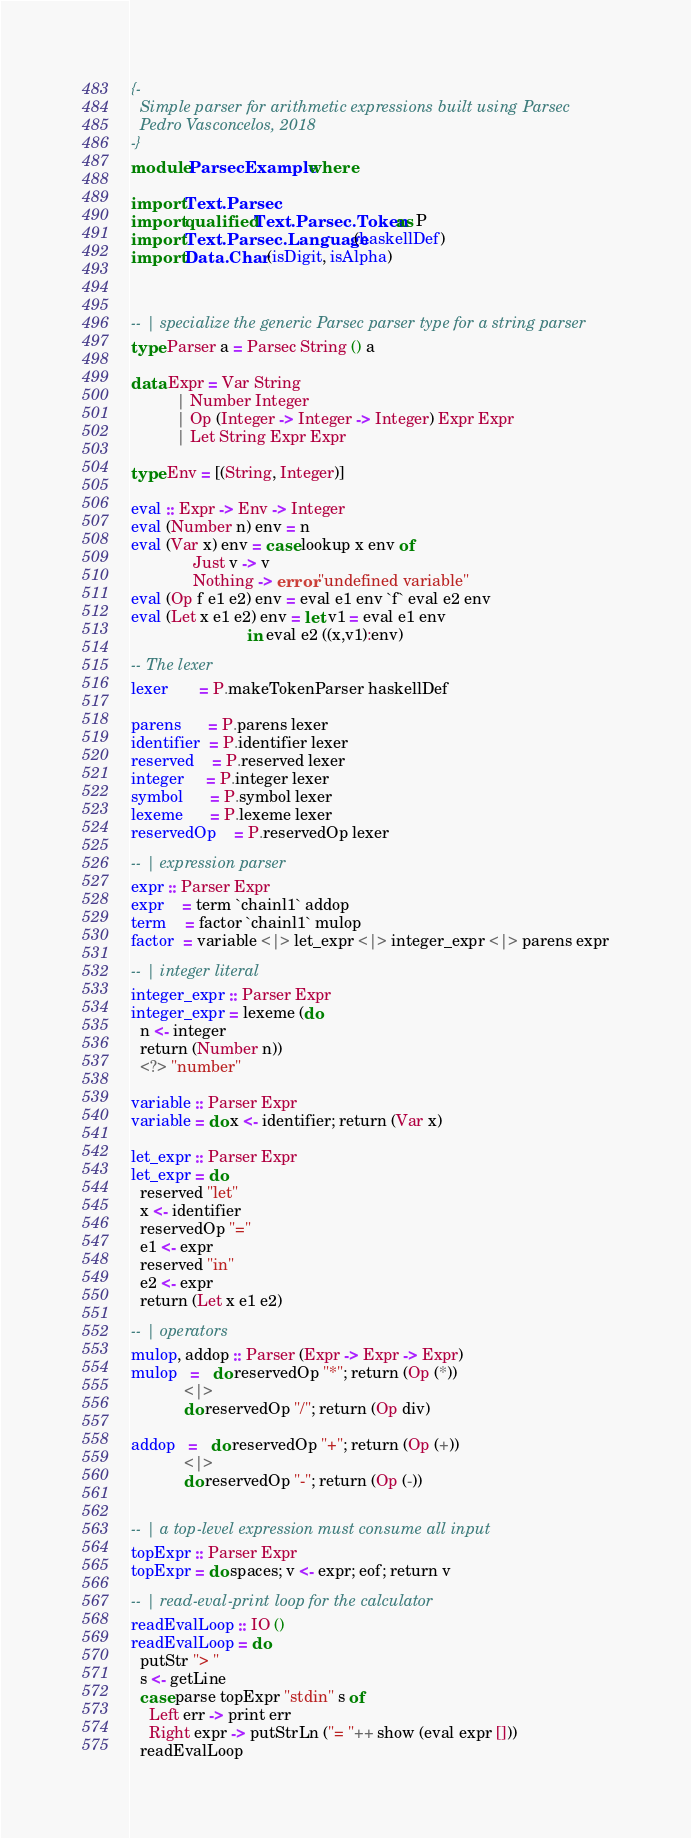<code> <loc_0><loc_0><loc_500><loc_500><_Haskell_>{-
  Simple parser for arithmetic expressions built using Parsec
  Pedro Vasconcelos, 2018
-}
module ParsecExample where

import Text.Parsec
import qualified Text.Parsec.Token as P
import Text.Parsec.Language (haskellDef)
import Data.Char (isDigit, isAlpha)



-- | specialize the generic Parsec parser type for a string parser
type Parser a = Parsec String () a

data Expr = Var String
          | Number Integer
          | Op (Integer -> Integer -> Integer) Expr Expr
          | Let String Expr Expr

type Env = [(String, Integer)]

eval :: Expr -> Env -> Integer
eval (Number n) env = n
eval (Var x) env = case lookup x env of
              Just v -> v
              Nothing -> error "undefined variable"
eval (Op f e1 e2) env = eval e1 env `f` eval e2 env
eval (Let x e1 e2) env = let v1 = eval e1 env
                          in eval e2 ((x,v1):env)

-- The lexer
lexer       = P.makeTokenParser haskellDef

parens      = P.parens lexer
identifier  = P.identifier lexer
reserved    = P.reserved lexer
integer     = P.integer lexer
symbol      = P.symbol lexer
lexeme      = P.lexeme lexer
reservedOp    = P.reservedOp lexer

-- | expression parser
expr :: Parser Expr
expr    = term `chainl1` addop
term    = factor `chainl1` mulop
factor  = variable <|> let_expr <|> integer_expr <|> parens expr

-- | integer literal
integer_expr :: Parser Expr
integer_expr = lexeme (do
  n <- integer
  return (Number n))
  <?> "number"

variable :: Parser Expr
variable = do x <- identifier; return (Var x)

let_expr :: Parser Expr
let_expr = do
  reserved "let"
  x <- identifier
  reservedOp "="
  e1 <- expr
  reserved "in"
  e2 <- expr
  return (Let x e1 e2)

-- | operators
mulop, addop :: Parser (Expr -> Expr -> Expr)
mulop   =   do reservedOp "*"; return (Op (*))
            <|>
            do reservedOp "/"; return (Op div)

addop   =   do reservedOp "+"; return (Op (+))
            <|>
            do reservedOp "-"; return (Op (-))


-- | a top-level expression must consume all input
topExpr :: Parser Expr
topExpr = do spaces; v <- expr; eof; return v

-- | read-eval-print loop for the calculator
readEvalLoop :: IO ()
readEvalLoop = do
  putStr "> "
  s <- getLine
  case parse topExpr "stdin" s of
    Left err -> print err
    Right expr -> putStrLn ("= "++ show (eval expr []))
  readEvalLoop
</code> 